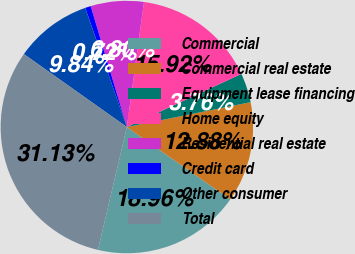Convert chart. <chart><loc_0><loc_0><loc_500><loc_500><pie_chart><fcel>Commercial<fcel>Commercial real estate<fcel>Equipment lease financing<fcel>Home equity<fcel>Residential real estate<fcel>Credit card<fcel>Other consumer<fcel>Total<nl><fcel>18.96%<fcel>12.88%<fcel>3.76%<fcel>15.92%<fcel>6.8%<fcel>0.72%<fcel>9.84%<fcel>31.13%<nl></chart> 